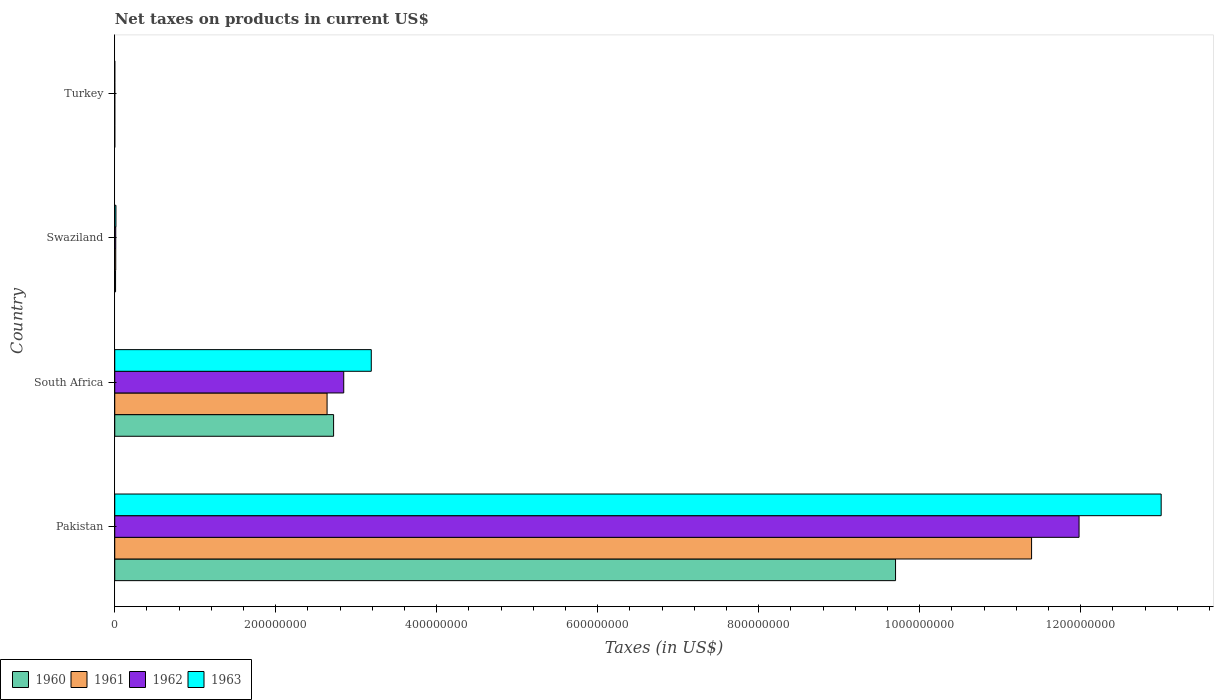How many groups of bars are there?
Make the answer very short. 4. Are the number of bars per tick equal to the number of legend labels?
Give a very brief answer. Yes. What is the label of the 2nd group of bars from the top?
Your response must be concise. Swaziland. What is the net taxes on products in 1963 in Pakistan?
Your answer should be compact. 1.30e+09. Across all countries, what is the maximum net taxes on products in 1962?
Give a very brief answer. 1.20e+09. Across all countries, what is the minimum net taxes on products in 1962?
Ensure brevity in your answer.  1600. In which country was the net taxes on products in 1961 minimum?
Keep it short and to the point. Turkey. What is the total net taxes on products in 1962 in the graph?
Your answer should be compact. 1.48e+09. What is the difference between the net taxes on products in 1960 in Pakistan and that in Turkey?
Provide a short and direct response. 9.70e+08. What is the difference between the net taxes on products in 1960 in Swaziland and the net taxes on products in 1962 in Pakistan?
Offer a terse response. -1.20e+09. What is the average net taxes on products in 1962 per country?
Provide a succinct answer. 3.71e+08. What is the difference between the net taxes on products in 1962 and net taxes on products in 1963 in Swaziland?
Your answer should be compact. -2.36e+05. In how many countries, is the net taxes on products in 1960 greater than 920000000 US$?
Make the answer very short. 1. What is the ratio of the net taxes on products in 1963 in Pakistan to that in Swaziland?
Make the answer very short. 881.71. What is the difference between the highest and the second highest net taxes on products in 1961?
Provide a succinct answer. 8.75e+08. What is the difference between the highest and the lowest net taxes on products in 1963?
Keep it short and to the point. 1.30e+09. Is it the case that in every country, the sum of the net taxes on products in 1962 and net taxes on products in 1960 is greater than the sum of net taxes on products in 1963 and net taxes on products in 1961?
Offer a terse response. No. What does the 2nd bar from the top in Swaziland represents?
Give a very brief answer. 1962. How many bars are there?
Your answer should be compact. 16. Are all the bars in the graph horizontal?
Your answer should be very brief. Yes. Are the values on the major ticks of X-axis written in scientific E-notation?
Your answer should be compact. No. Where does the legend appear in the graph?
Keep it short and to the point. Bottom left. How many legend labels are there?
Give a very brief answer. 4. How are the legend labels stacked?
Offer a terse response. Horizontal. What is the title of the graph?
Make the answer very short. Net taxes on products in current US$. What is the label or title of the X-axis?
Ensure brevity in your answer.  Taxes (in US$). What is the label or title of the Y-axis?
Give a very brief answer. Country. What is the Taxes (in US$) in 1960 in Pakistan?
Make the answer very short. 9.70e+08. What is the Taxes (in US$) in 1961 in Pakistan?
Provide a succinct answer. 1.14e+09. What is the Taxes (in US$) in 1962 in Pakistan?
Keep it short and to the point. 1.20e+09. What is the Taxes (in US$) of 1963 in Pakistan?
Provide a succinct answer. 1.30e+09. What is the Taxes (in US$) of 1960 in South Africa?
Your answer should be very brief. 2.72e+08. What is the Taxes (in US$) in 1961 in South Africa?
Give a very brief answer. 2.64e+08. What is the Taxes (in US$) of 1962 in South Africa?
Your response must be concise. 2.84e+08. What is the Taxes (in US$) of 1963 in South Africa?
Make the answer very short. 3.19e+08. What is the Taxes (in US$) in 1960 in Swaziland?
Your answer should be very brief. 1.00e+06. What is the Taxes (in US$) in 1961 in Swaziland?
Make the answer very short. 1.21e+06. What is the Taxes (in US$) of 1962 in Swaziland?
Offer a very short reply. 1.24e+06. What is the Taxes (in US$) of 1963 in Swaziland?
Give a very brief answer. 1.47e+06. What is the Taxes (in US$) in 1960 in Turkey?
Make the answer very short. 1300. What is the Taxes (in US$) in 1961 in Turkey?
Keep it short and to the point. 1500. What is the Taxes (in US$) of 1962 in Turkey?
Make the answer very short. 1600. What is the Taxes (in US$) of 1963 in Turkey?
Make the answer very short. 1800. Across all countries, what is the maximum Taxes (in US$) of 1960?
Offer a very short reply. 9.70e+08. Across all countries, what is the maximum Taxes (in US$) in 1961?
Provide a succinct answer. 1.14e+09. Across all countries, what is the maximum Taxes (in US$) in 1962?
Ensure brevity in your answer.  1.20e+09. Across all countries, what is the maximum Taxes (in US$) in 1963?
Make the answer very short. 1.30e+09. Across all countries, what is the minimum Taxes (in US$) in 1960?
Give a very brief answer. 1300. Across all countries, what is the minimum Taxes (in US$) of 1961?
Offer a terse response. 1500. Across all countries, what is the minimum Taxes (in US$) of 1962?
Your answer should be compact. 1600. Across all countries, what is the minimum Taxes (in US$) in 1963?
Offer a very short reply. 1800. What is the total Taxes (in US$) of 1960 in the graph?
Your answer should be very brief. 1.24e+09. What is the total Taxes (in US$) of 1961 in the graph?
Give a very brief answer. 1.40e+09. What is the total Taxes (in US$) of 1962 in the graph?
Keep it short and to the point. 1.48e+09. What is the total Taxes (in US$) in 1963 in the graph?
Your answer should be very brief. 1.62e+09. What is the difference between the Taxes (in US$) in 1960 in Pakistan and that in South Africa?
Provide a succinct answer. 6.98e+08. What is the difference between the Taxes (in US$) of 1961 in Pakistan and that in South Africa?
Keep it short and to the point. 8.75e+08. What is the difference between the Taxes (in US$) in 1962 in Pakistan and that in South Africa?
Keep it short and to the point. 9.14e+08. What is the difference between the Taxes (in US$) of 1963 in Pakistan and that in South Africa?
Keep it short and to the point. 9.81e+08. What is the difference between the Taxes (in US$) of 1960 in Pakistan and that in Swaziland?
Make the answer very short. 9.69e+08. What is the difference between the Taxes (in US$) of 1961 in Pakistan and that in Swaziland?
Make the answer very short. 1.14e+09. What is the difference between the Taxes (in US$) of 1962 in Pakistan and that in Swaziland?
Offer a terse response. 1.20e+09. What is the difference between the Taxes (in US$) in 1963 in Pakistan and that in Swaziland?
Ensure brevity in your answer.  1.30e+09. What is the difference between the Taxes (in US$) of 1960 in Pakistan and that in Turkey?
Your answer should be very brief. 9.70e+08. What is the difference between the Taxes (in US$) of 1961 in Pakistan and that in Turkey?
Offer a very short reply. 1.14e+09. What is the difference between the Taxes (in US$) of 1962 in Pakistan and that in Turkey?
Offer a terse response. 1.20e+09. What is the difference between the Taxes (in US$) in 1963 in Pakistan and that in Turkey?
Provide a short and direct response. 1.30e+09. What is the difference between the Taxes (in US$) of 1960 in South Africa and that in Swaziland?
Your answer should be very brief. 2.71e+08. What is the difference between the Taxes (in US$) in 1961 in South Africa and that in Swaziland?
Provide a succinct answer. 2.63e+08. What is the difference between the Taxes (in US$) of 1962 in South Africa and that in Swaziland?
Offer a terse response. 2.83e+08. What is the difference between the Taxes (in US$) in 1963 in South Africa and that in Swaziland?
Keep it short and to the point. 3.17e+08. What is the difference between the Taxes (in US$) of 1960 in South Africa and that in Turkey?
Your response must be concise. 2.72e+08. What is the difference between the Taxes (in US$) in 1961 in South Africa and that in Turkey?
Keep it short and to the point. 2.64e+08. What is the difference between the Taxes (in US$) in 1962 in South Africa and that in Turkey?
Your response must be concise. 2.84e+08. What is the difference between the Taxes (in US$) in 1963 in South Africa and that in Turkey?
Your response must be concise. 3.19e+08. What is the difference between the Taxes (in US$) of 1960 in Swaziland and that in Turkey?
Your response must be concise. 1.00e+06. What is the difference between the Taxes (in US$) of 1961 in Swaziland and that in Turkey?
Your answer should be very brief. 1.21e+06. What is the difference between the Taxes (in US$) in 1962 in Swaziland and that in Turkey?
Your answer should be very brief. 1.24e+06. What is the difference between the Taxes (in US$) in 1963 in Swaziland and that in Turkey?
Your response must be concise. 1.47e+06. What is the difference between the Taxes (in US$) of 1960 in Pakistan and the Taxes (in US$) of 1961 in South Africa?
Your response must be concise. 7.06e+08. What is the difference between the Taxes (in US$) of 1960 in Pakistan and the Taxes (in US$) of 1962 in South Africa?
Your response must be concise. 6.86e+08. What is the difference between the Taxes (in US$) in 1960 in Pakistan and the Taxes (in US$) in 1963 in South Africa?
Your answer should be very brief. 6.51e+08. What is the difference between the Taxes (in US$) of 1961 in Pakistan and the Taxes (in US$) of 1962 in South Africa?
Provide a succinct answer. 8.55e+08. What is the difference between the Taxes (in US$) in 1961 in Pakistan and the Taxes (in US$) in 1963 in South Africa?
Offer a very short reply. 8.20e+08. What is the difference between the Taxes (in US$) in 1962 in Pakistan and the Taxes (in US$) in 1963 in South Africa?
Your response must be concise. 8.79e+08. What is the difference between the Taxes (in US$) in 1960 in Pakistan and the Taxes (in US$) in 1961 in Swaziland?
Ensure brevity in your answer.  9.69e+08. What is the difference between the Taxes (in US$) in 1960 in Pakistan and the Taxes (in US$) in 1962 in Swaziland?
Offer a very short reply. 9.69e+08. What is the difference between the Taxes (in US$) in 1960 in Pakistan and the Taxes (in US$) in 1963 in Swaziland?
Provide a short and direct response. 9.69e+08. What is the difference between the Taxes (in US$) in 1961 in Pakistan and the Taxes (in US$) in 1962 in Swaziland?
Your answer should be compact. 1.14e+09. What is the difference between the Taxes (in US$) of 1961 in Pakistan and the Taxes (in US$) of 1963 in Swaziland?
Keep it short and to the point. 1.14e+09. What is the difference between the Taxes (in US$) in 1962 in Pakistan and the Taxes (in US$) in 1963 in Swaziland?
Your answer should be very brief. 1.20e+09. What is the difference between the Taxes (in US$) of 1960 in Pakistan and the Taxes (in US$) of 1961 in Turkey?
Give a very brief answer. 9.70e+08. What is the difference between the Taxes (in US$) of 1960 in Pakistan and the Taxes (in US$) of 1962 in Turkey?
Provide a succinct answer. 9.70e+08. What is the difference between the Taxes (in US$) in 1960 in Pakistan and the Taxes (in US$) in 1963 in Turkey?
Give a very brief answer. 9.70e+08. What is the difference between the Taxes (in US$) in 1961 in Pakistan and the Taxes (in US$) in 1962 in Turkey?
Offer a very short reply. 1.14e+09. What is the difference between the Taxes (in US$) of 1961 in Pakistan and the Taxes (in US$) of 1963 in Turkey?
Your answer should be very brief. 1.14e+09. What is the difference between the Taxes (in US$) in 1962 in Pakistan and the Taxes (in US$) in 1963 in Turkey?
Your answer should be compact. 1.20e+09. What is the difference between the Taxes (in US$) in 1960 in South Africa and the Taxes (in US$) in 1961 in Swaziland?
Ensure brevity in your answer.  2.71e+08. What is the difference between the Taxes (in US$) of 1960 in South Africa and the Taxes (in US$) of 1962 in Swaziland?
Ensure brevity in your answer.  2.71e+08. What is the difference between the Taxes (in US$) in 1960 in South Africa and the Taxes (in US$) in 1963 in Swaziland?
Provide a short and direct response. 2.70e+08. What is the difference between the Taxes (in US$) of 1961 in South Africa and the Taxes (in US$) of 1962 in Swaziland?
Offer a very short reply. 2.63e+08. What is the difference between the Taxes (in US$) in 1961 in South Africa and the Taxes (in US$) in 1963 in Swaziland?
Provide a succinct answer. 2.62e+08. What is the difference between the Taxes (in US$) of 1962 in South Africa and the Taxes (in US$) of 1963 in Swaziland?
Provide a succinct answer. 2.83e+08. What is the difference between the Taxes (in US$) of 1960 in South Africa and the Taxes (in US$) of 1961 in Turkey?
Give a very brief answer. 2.72e+08. What is the difference between the Taxes (in US$) of 1960 in South Africa and the Taxes (in US$) of 1962 in Turkey?
Your answer should be very brief. 2.72e+08. What is the difference between the Taxes (in US$) of 1960 in South Africa and the Taxes (in US$) of 1963 in Turkey?
Your response must be concise. 2.72e+08. What is the difference between the Taxes (in US$) of 1961 in South Africa and the Taxes (in US$) of 1962 in Turkey?
Give a very brief answer. 2.64e+08. What is the difference between the Taxes (in US$) in 1961 in South Africa and the Taxes (in US$) in 1963 in Turkey?
Ensure brevity in your answer.  2.64e+08. What is the difference between the Taxes (in US$) in 1962 in South Africa and the Taxes (in US$) in 1963 in Turkey?
Your response must be concise. 2.84e+08. What is the difference between the Taxes (in US$) of 1960 in Swaziland and the Taxes (in US$) of 1961 in Turkey?
Give a very brief answer. 1.00e+06. What is the difference between the Taxes (in US$) in 1960 in Swaziland and the Taxes (in US$) in 1962 in Turkey?
Your answer should be compact. 1.00e+06. What is the difference between the Taxes (in US$) of 1960 in Swaziland and the Taxes (in US$) of 1963 in Turkey?
Make the answer very short. 1.00e+06. What is the difference between the Taxes (in US$) in 1961 in Swaziland and the Taxes (in US$) in 1962 in Turkey?
Make the answer very short. 1.21e+06. What is the difference between the Taxes (in US$) of 1961 in Swaziland and the Taxes (in US$) of 1963 in Turkey?
Your answer should be compact. 1.21e+06. What is the difference between the Taxes (in US$) of 1962 in Swaziland and the Taxes (in US$) of 1963 in Turkey?
Give a very brief answer. 1.24e+06. What is the average Taxes (in US$) in 1960 per country?
Your answer should be compact. 3.11e+08. What is the average Taxes (in US$) in 1961 per country?
Your answer should be compact. 3.51e+08. What is the average Taxes (in US$) in 1962 per country?
Ensure brevity in your answer.  3.71e+08. What is the average Taxes (in US$) of 1963 per country?
Provide a short and direct response. 4.05e+08. What is the difference between the Taxes (in US$) of 1960 and Taxes (in US$) of 1961 in Pakistan?
Provide a short and direct response. -1.69e+08. What is the difference between the Taxes (in US$) in 1960 and Taxes (in US$) in 1962 in Pakistan?
Offer a very short reply. -2.28e+08. What is the difference between the Taxes (in US$) of 1960 and Taxes (in US$) of 1963 in Pakistan?
Give a very brief answer. -3.30e+08. What is the difference between the Taxes (in US$) in 1961 and Taxes (in US$) in 1962 in Pakistan?
Your answer should be very brief. -5.90e+07. What is the difference between the Taxes (in US$) of 1961 and Taxes (in US$) of 1963 in Pakistan?
Provide a short and direct response. -1.61e+08. What is the difference between the Taxes (in US$) in 1962 and Taxes (in US$) in 1963 in Pakistan?
Give a very brief answer. -1.02e+08. What is the difference between the Taxes (in US$) of 1960 and Taxes (in US$) of 1961 in South Africa?
Keep it short and to the point. 8.10e+06. What is the difference between the Taxes (in US$) in 1960 and Taxes (in US$) in 1962 in South Africa?
Offer a very short reply. -1.26e+07. What is the difference between the Taxes (in US$) of 1960 and Taxes (in US$) of 1963 in South Africa?
Your answer should be very brief. -4.68e+07. What is the difference between the Taxes (in US$) of 1961 and Taxes (in US$) of 1962 in South Africa?
Ensure brevity in your answer.  -2.07e+07. What is the difference between the Taxes (in US$) in 1961 and Taxes (in US$) in 1963 in South Africa?
Make the answer very short. -5.49e+07. What is the difference between the Taxes (in US$) of 1962 and Taxes (in US$) of 1963 in South Africa?
Give a very brief answer. -3.42e+07. What is the difference between the Taxes (in US$) of 1960 and Taxes (in US$) of 1961 in Swaziland?
Your answer should be compact. -2.06e+05. What is the difference between the Taxes (in US$) in 1960 and Taxes (in US$) in 1962 in Swaziland?
Provide a succinct answer. -2.36e+05. What is the difference between the Taxes (in US$) in 1960 and Taxes (in US$) in 1963 in Swaziland?
Your response must be concise. -4.72e+05. What is the difference between the Taxes (in US$) of 1961 and Taxes (in US$) of 1962 in Swaziland?
Your answer should be very brief. -2.95e+04. What is the difference between the Taxes (in US$) of 1961 and Taxes (in US$) of 1963 in Swaziland?
Provide a short and direct response. -2.65e+05. What is the difference between the Taxes (in US$) of 1962 and Taxes (in US$) of 1963 in Swaziland?
Your answer should be compact. -2.36e+05. What is the difference between the Taxes (in US$) in 1960 and Taxes (in US$) in 1961 in Turkey?
Your answer should be very brief. -200. What is the difference between the Taxes (in US$) in 1960 and Taxes (in US$) in 1962 in Turkey?
Your response must be concise. -300. What is the difference between the Taxes (in US$) in 1960 and Taxes (in US$) in 1963 in Turkey?
Offer a terse response. -500. What is the difference between the Taxes (in US$) in 1961 and Taxes (in US$) in 1962 in Turkey?
Give a very brief answer. -100. What is the difference between the Taxes (in US$) of 1961 and Taxes (in US$) of 1963 in Turkey?
Your answer should be very brief. -300. What is the difference between the Taxes (in US$) of 1962 and Taxes (in US$) of 1963 in Turkey?
Your answer should be compact. -200. What is the ratio of the Taxes (in US$) of 1960 in Pakistan to that in South Africa?
Offer a terse response. 3.57. What is the ratio of the Taxes (in US$) in 1961 in Pakistan to that in South Africa?
Make the answer very short. 4.32. What is the ratio of the Taxes (in US$) in 1962 in Pakistan to that in South Africa?
Ensure brevity in your answer.  4.21. What is the ratio of the Taxes (in US$) in 1963 in Pakistan to that in South Africa?
Your answer should be compact. 4.08. What is the ratio of the Taxes (in US$) in 1960 in Pakistan to that in Swaziland?
Ensure brevity in your answer.  967.48. What is the ratio of the Taxes (in US$) of 1961 in Pakistan to that in Swaziland?
Your response must be concise. 942.1. What is the ratio of the Taxes (in US$) of 1962 in Pakistan to that in Swaziland?
Provide a short and direct response. 967.3. What is the ratio of the Taxes (in US$) in 1963 in Pakistan to that in Swaziland?
Your answer should be very brief. 881.71. What is the ratio of the Taxes (in US$) in 1960 in Pakistan to that in Turkey?
Your response must be concise. 7.46e+05. What is the ratio of the Taxes (in US$) in 1961 in Pakistan to that in Turkey?
Ensure brevity in your answer.  7.59e+05. What is the ratio of the Taxes (in US$) in 1962 in Pakistan to that in Turkey?
Your response must be concise. 7.49e+05. What is the ratio of the Taxes (in US$) of 1963 in Pakistan to that in Turkey?
Offer a terse response. 7.22e+05. What is the ratio of the Taxes (in US$) of 1960 in South Africa to that in Swaziland?
Offer a very short reply. 271.17. What is the ratio of the Taxes (in US$) in 1961 in South Africa to that in Swaziland?
Your answer should be very brief. 218.17. What is the ratio of the Taxes (in US$) of 1962 in South Africa to that in Swaziland?
Your answer should be very brief. 229.69. What is the ratio of the Taxes (in US$) of 1963 in South Africa to that in Swaziland?
Provide a short and direct response. 216.15. What is the ratio of the Taxes (in US$) of 1960 in South Africa to that in Turkey?
Keep it short and to the point. 2.09e+05. What is the ratio of the Taxes (in US$) in 1961 in South Africa to that in Turkey?
Your answer should be compact. 1.76e+05. What is the ratio of the Taxes (in US$) of 1962 in South Africa to that in Turkey?
Keep it short and to the point. 1.78e+05. What is the ratio of the Taxes (in US$) in 1963 in South Africa to that in Turkey?
Offer a terse response. 1.77e+05. What is the ratio of the Taxes (in US$) in 1960 in Swaziland to that in Turkey?
Provide a short and direct response. 771.23. What is the ratio of the Taxes (in US$) of 1961 in Swaziland to that in Turkey?
Provide a short and direct response. 806. What is the ratio of the Taxes (in US$) of 1962 in Swaziland to that in Turkey?
Make the answer very short. 774.06. What is the ratio of the Taxes (in US$) of 1963 in Swaziland to that in Turkey?
Provide a short and direct response. 819.11. What is the difference between the highest and the second highest Taxes (in US$) in 1960?
Provide a short and direct response. 6.98e+08. What is the difference between the highest and the second highest Taxes (in US$) in 1961?
Your response must be concise. 8.75e+08. What is the difference between the highest and the second highest Taxes (in US$) of 1962?
Offer a terse response. 9.14e+08. What is the difference between the highest and the second highest Taxes (in US$) of 1963?
Give a very brief answer. 9.81e+08. What is the difference between the highest and the lowest Taxes (in US$) in 1960?
Offer a terse response. 9.70e+08. What is the difference between the highest and the lowest Taxes (in US$) of 1961?
Provide a short and direct response. 1.14e+09. What is the difference between the highest and the lowest Taxes (in US$) in 1962?
Provide a short and direct response. 1.20e+09. What is the difference between the highest and the lowest Taxes (in US$) of 1963?
Give a very brief answer. 1.30e+09. 